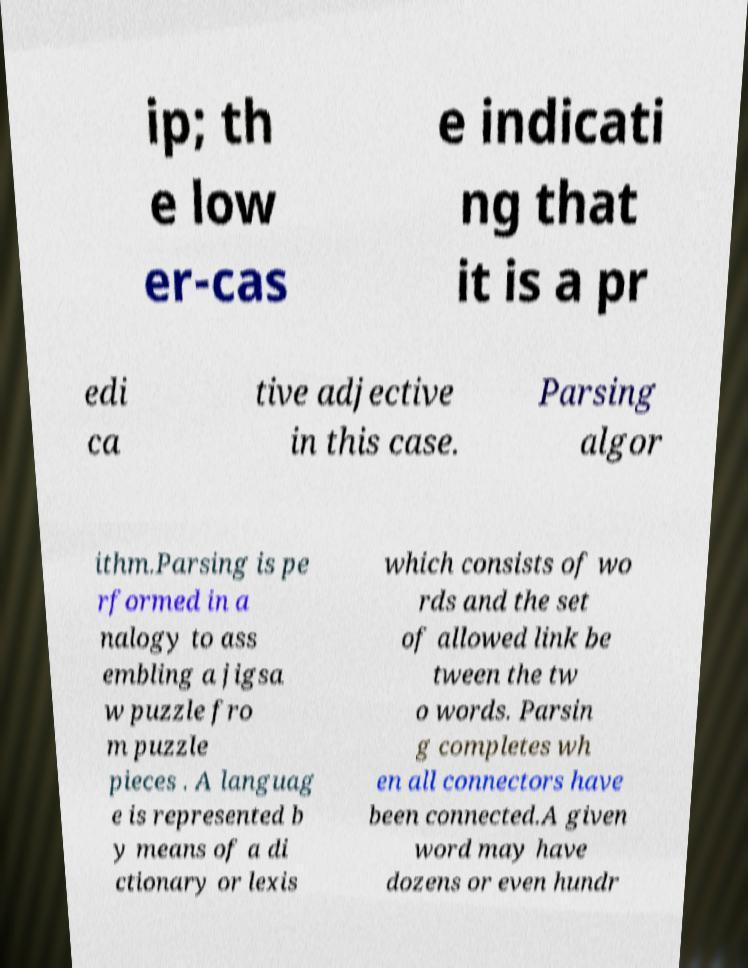Can you accurately transcribe the text from the provided image for me? ip; th e low er-cas e indicati ng that it is a pr edi ca tive adjective in this case. Parsing algor ithm.Parsing is pe rformed in a nalogy to ass embling a jigsa w puzzle fro m puzzle pieces . A languag e is represented b y means of a di ctionary or lexis which consists of wo rds and the set of allowed link be tween the tw o words. Parsin g completes wh en all connectors have been connected.A given word may have dozens or even hundr 